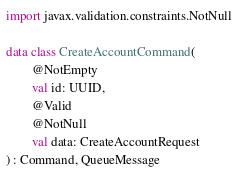Convert code to text. <code><loc_0><loc_0><loc_500><loc_500><_Kotlin_>import javax.validation.constraints.NotNull

data class CreateAccountCommand(
        @NotEmpty
        val id: UUID,
        @Valid
        @NotNull
        val data: CreateAccountRequest
) : Command, QueueMessage</code> 